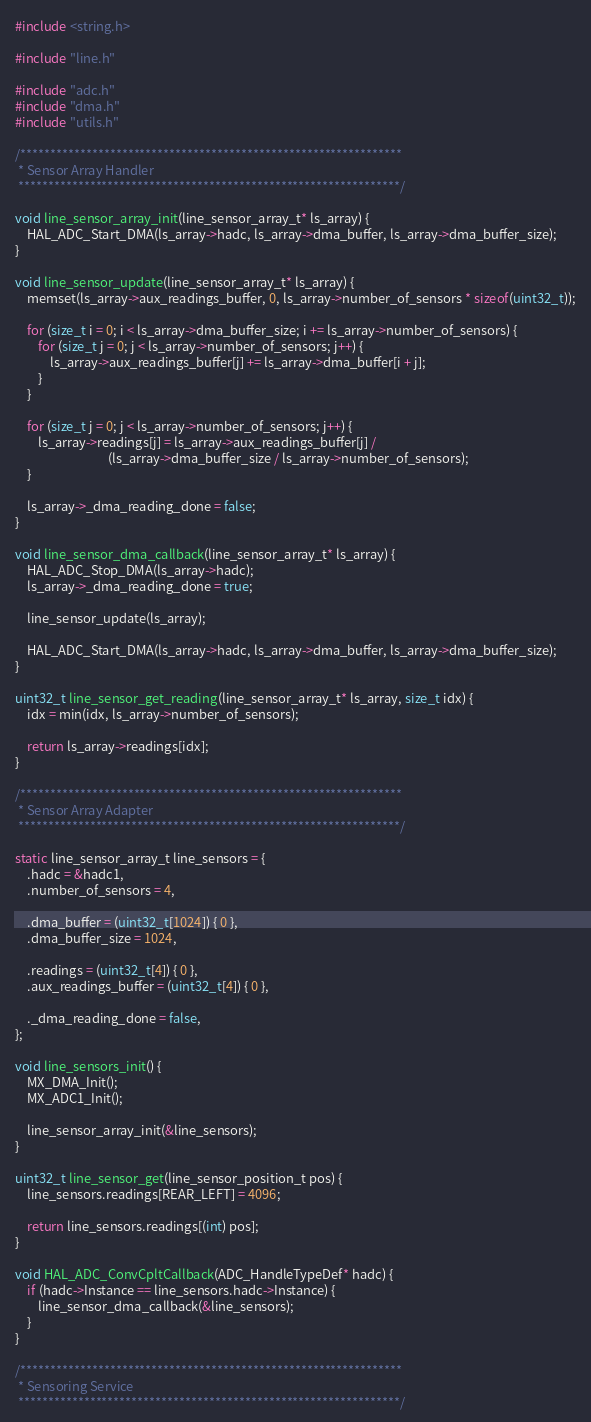Convert code to text. <code><loc_0><loc_0><loc_500><loc_500><_C_>#include <string.h>

#include "line.h"

#include "adc.h"
#include "dma.h"
#include "utils.h"

/****************************************************************
 * Sensor Array Handler
 ****************************************************************/

void line_sensor_array_init(line_sensor_array_t* ls_array) {
    HAL_ADC_Start_DMA(ls_array->hadc, ls_array->dma_buffer, ls_array->dma_buffer_size);
}

void line_sensor_update(line_sensor_array_t* ls_array) {
    memset(ls_array->aux_readings_buffer, 0, ls_array->number_of_sensors * sizeof(uint32_t));

    for (size_t i = 0; i < ls_array->dma_buffer_size; i += ls_array->number_of_sensors) {
        for (size_t j = 0; j < ls_array->number_of_sensors; j++) {
            ls_array->aux_readings_buffer[j] += ls_array->dma_buffer[i + j];
        }
    }

    for (size_t j = 0; j < ls_array->number_of_sensors; j++) {
        ls_array->readings[j] = ls_array->aux_readings_buffer[j] /
                                (ls_array->dma_buffer_size / ls_array->number_of_sensors);
    }

    ls_array->_dma_reading_done = false;
}

void line_sensor_dma_callback(line_sensor_array_t* ls_array) {
    HAL_ADC_Stop_DMA(ls_array->hadc);
    ls_array->_dma_reading_done = true;

    line_sensor_update(ls_array);

    HAL_ADC_Start_DMA(ls_array->hadc, ls_array->dma_buffer, ls_array->dma_buffer_size);
}

uint32_t line_sensor_get_reading(line_sensor_array_t* ls_array, size_t idx) {
    idx = min(idx, ls_array->number_of_sensors);

    return ls_array->readings[idx];
}

/****************************************************************
 * Sensor Array Adapter
 ****************************************************************/

static line_sensor_array_t line_sensors = {
    .hadc = &hadc1,
    .number_of_sensors = 4,

    .dma_buffer = (uint32_t[1024]) { 0 },
    .dma_buffer_size = 1024,

    .readings = (uint32_t[4]) { 0 },
    .aux_readings_buffer = (uint32_t[4]) { 0 },

    ._dma_reading_done = false,
};

void line_sensors_init() {
    MX_DMA_Init();
    MX_ADC1_Init();

    line_sensor_array_init(&line_sensors);
}

uint32_t line_sensor_get(line_sensor_position_t pos) {
    line_sensors.readings[REAR_LEFT] = 4096;

    return line_sensors.readings[(int) pos];
}

void HAL_ADC_ConvCpltCallback(ADC_HandleTypeDef* hadc) {
    if (hadc->Instance == line_sensors.hadc->Instance) {
        line_sensor_dma_callback(&line_sensors);
    }
}

/****************************************************************
 * Sensoring Service
 ****************************************************************/
</code> 